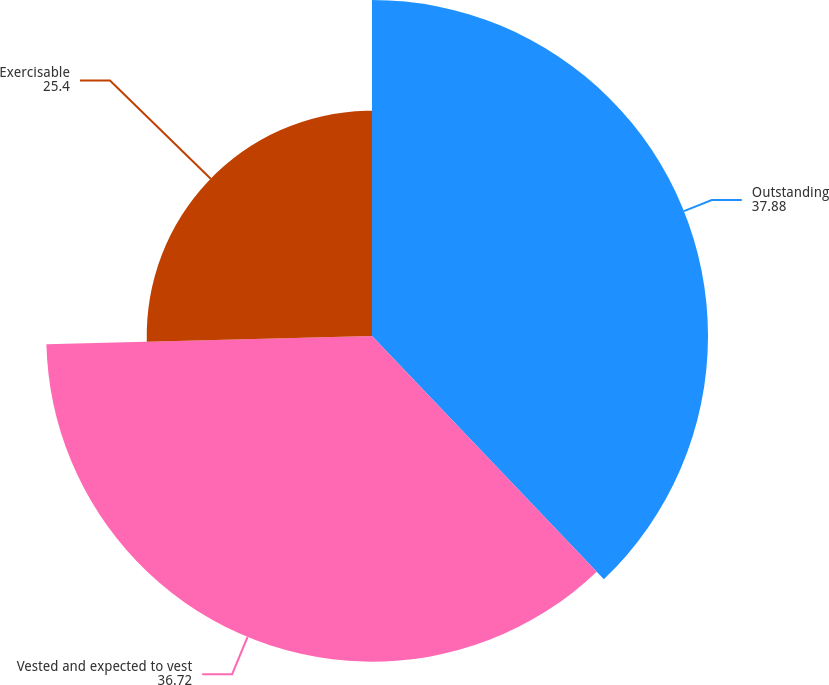Convert chart. <chart><loc_0><loc_0><loc_500><loc_500><pie_chart><fcel>Outstanding<fcel>Vested and expected to vest<fcel>Exercisable<nl><fcel>37.88%<fcel>36.72%<fcel>25.4%<nl></chart> 